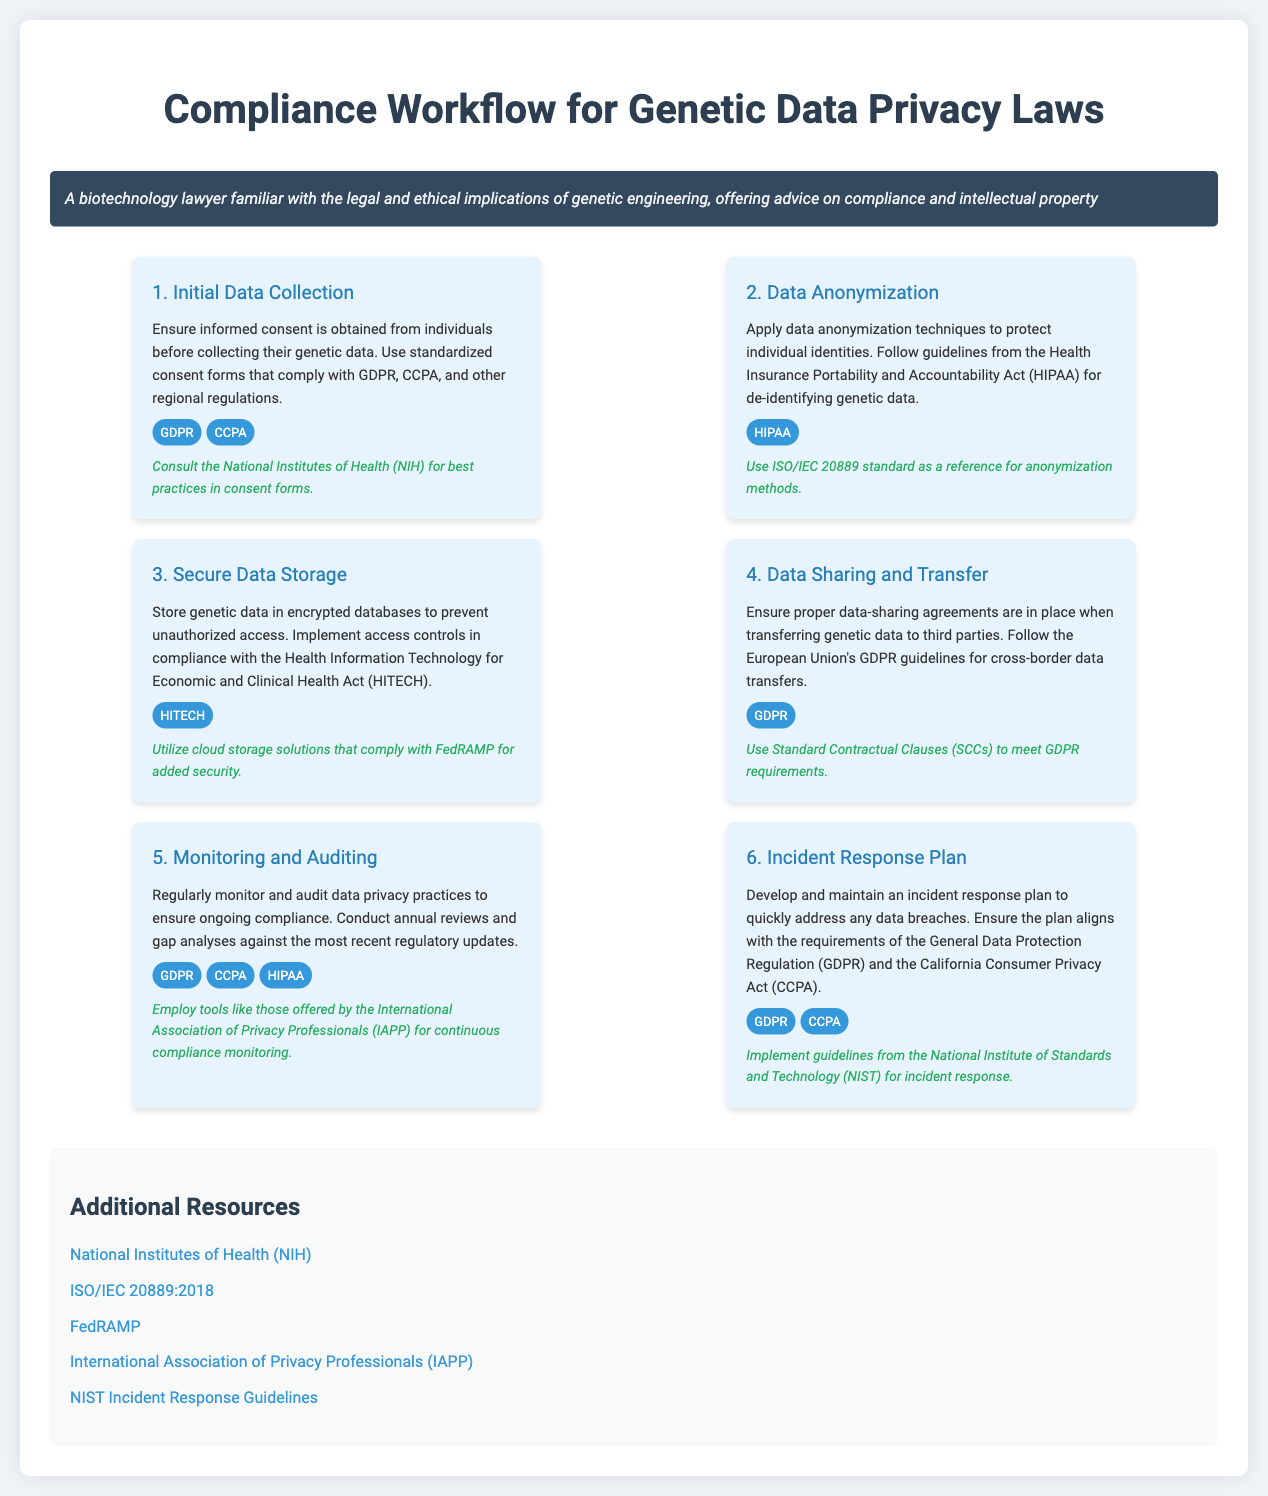What is the first step in the compliance workflow? The first step in the compliance workflow is to ensure informed consent is obtained from individuals before collecting their genetic data.
Answer: Initial Data Collection Which laws should the consent forms comply with? The consent forms should comply with GDPR and CCPA regulations.
Answer: GDPR, CCPA What data protection standard is recommended for use in anonymization methods? The recommended standard for anonymization methods is ISO/IEC 20889.
Answer: ISO/IEC 20889 What type of storage is advised for genetic data? The advice is to store genetic data in encrypted databases.
Answer: Encrypted databases How often should compliance practices be monitored and audited? Compliance practices should be monitored and audited regularly, with annual reviews conducted.
Answer: Annually Which two acts require the incident response plan to be aligned with? The incident response plan should align with GDPR and CCPA requirements.
Answer: GDPR, CCPA What organization’s guidelines are suggested for incident response? The guidelines suggested for incident response are from the National Institute of Standards and Technology (NIST).
Answer: NIST What is the purpose of using Standard Contractual Clauses in data sharing? Standard Contractual Clauses are used to meet GDPR requirements for cross-border data transfers.
Answer: Meet GDPR requirements Which organization provides resources for continuous compliance monitoring? The International Association of Privacy Professionals (IAPP) offers resources for continuous compliance monitoring.
Answer: IAPP 